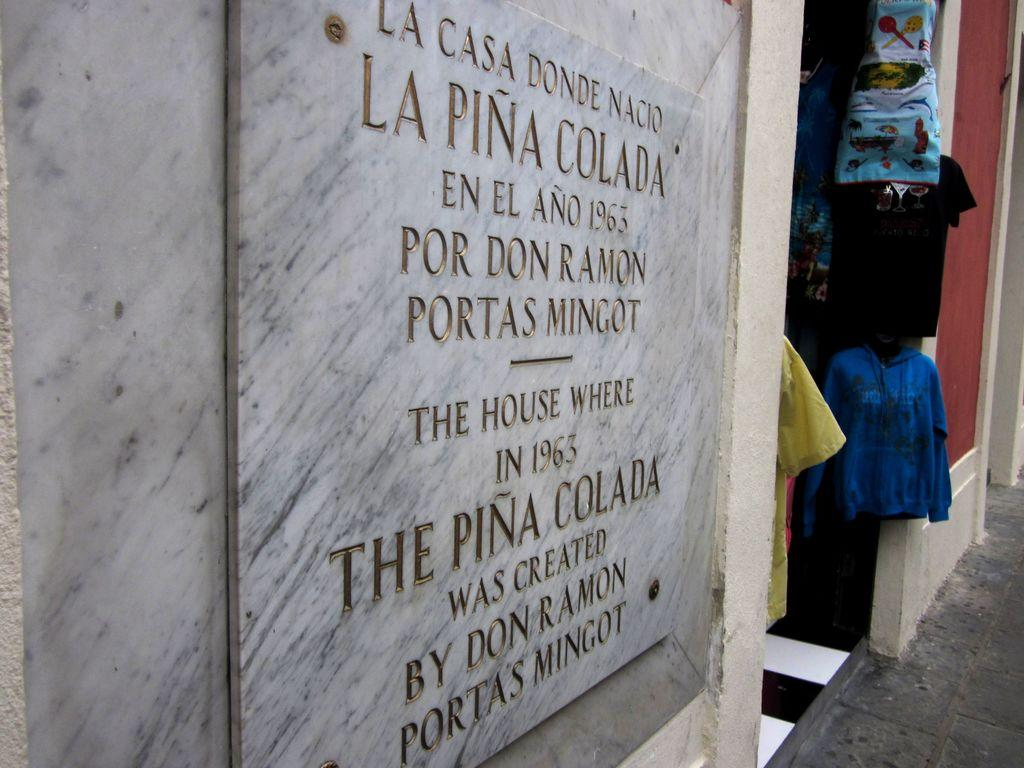What is written on in the foreground of the image? There is text on a stone in the foreground of the image. Where is the text located? The text is on a wall. What can be seen in the background of the image? There are clothes hanging in the background of the image. What type of surface is visible in the bottom right of the image? The pavement is visible in the bottom right of the image. What is your brother doing in the room depicted in the image? There is no room or brother present in the image; it features text on a stone and clothes hanging in the background. 